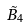<formula> <loc_0><loc_0><loc_500><loc_500>\tilde { B } _ { 4 }</formula> 